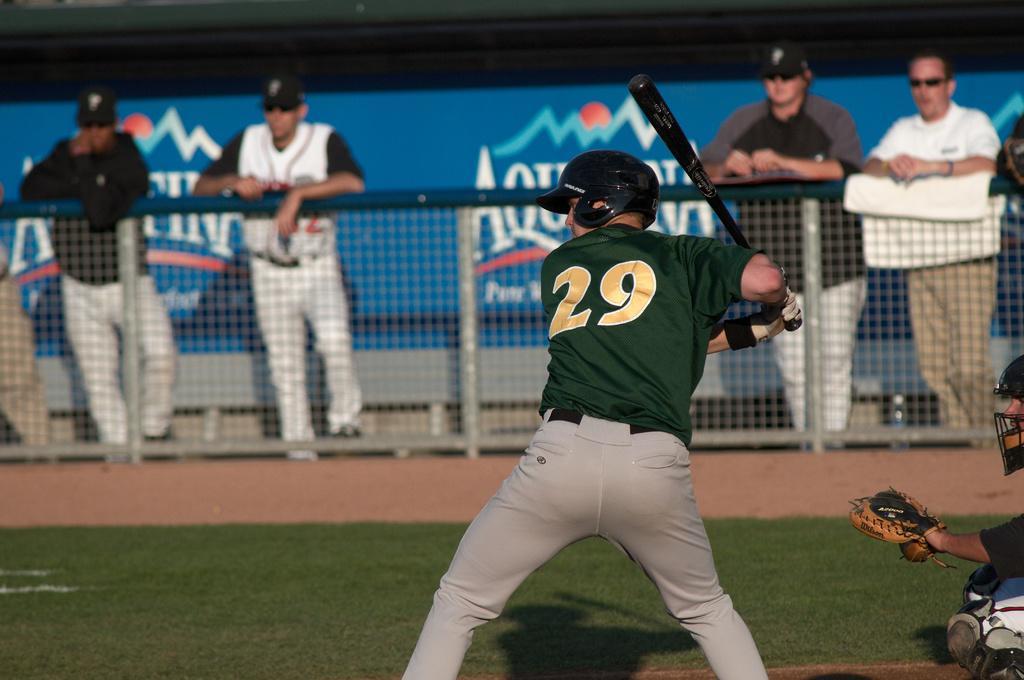How would you summarize this image in a sentence or two? This person is holding a bat and wore a helmet. Another person wore a helmet and gloves. Backside of this mesh there are people and hoarding.  